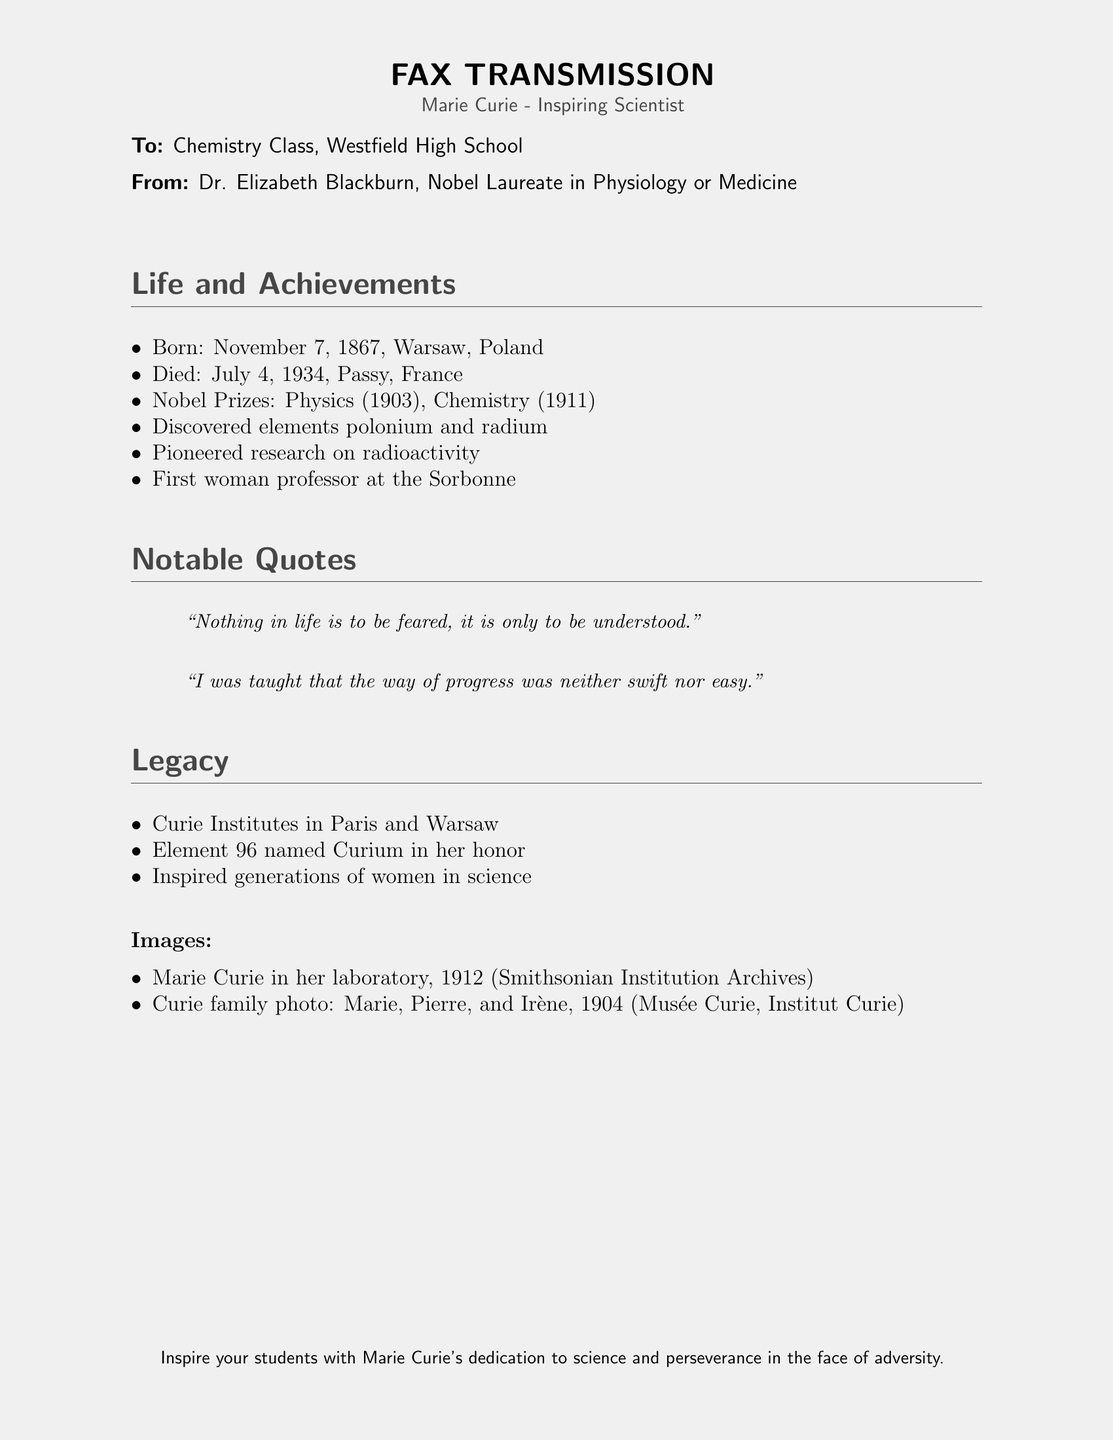What is Marie Curie's birth date? The document states she was born on November 7, 1867.
Answer: November 7, 1867 How many Nobel Prizes did Marie Curie win? According to the document, Marie Curie won two Nobel Prizes, in Physics and Chemistry.
Answer: Two What elements did Marie Curie discover? The document mentions that she discovered polonium and radium.
Answer: Polonium and radium What is the name of the institute named after Marie Curie? The document refers to the Curie Institutes in Paris and Warsaw.
Answer: Curie Institutes What notable quote emphasizes understanding over fear? The document features the quote: "Nothing in life is to be feared, it is only to be understood."
Answer: "Nothing in life is to be feared, it is only to be understood." How did Marie Curie's achievements impact women in science? According to the document, she inspired generations of women in science.
Answer: Inspired generations of women in science Who sent the fax? The document states it was sent by Dr. Elizabeth Blackburn.
Answer: Dr. Elizabeth Blackburn In which year did Marie Curie win her first Nobel Prize? The document indicates she won her first Nobel Prize in 1903.
Answer: 1903 